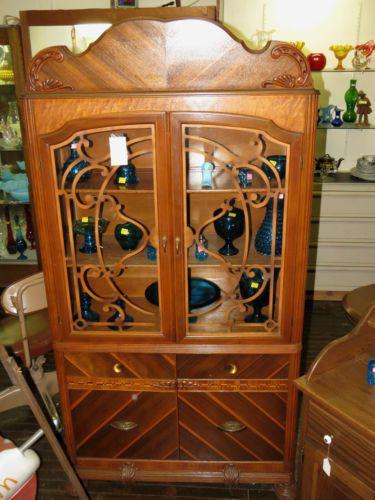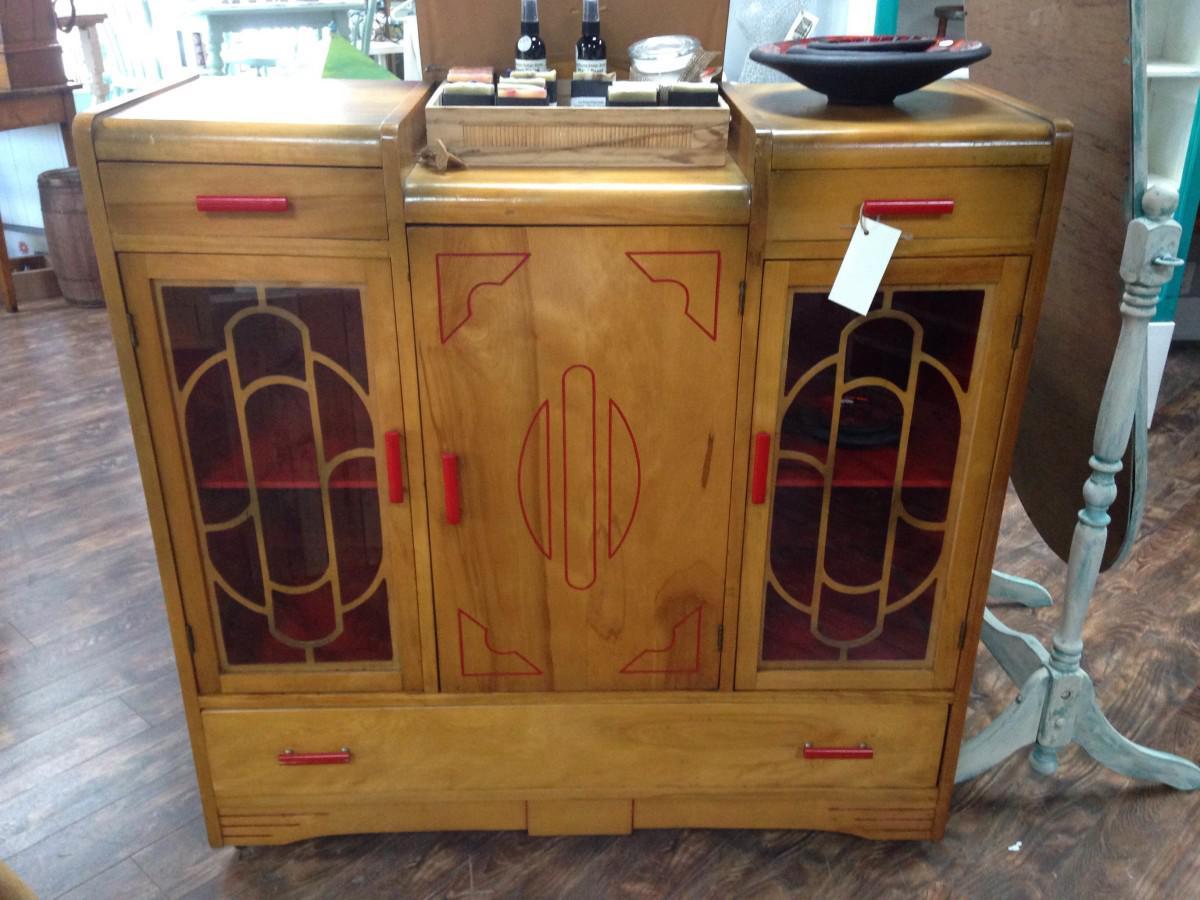The first image is the image on the left, the second image is the image on the right. Assess this claim about the two images: "Right image features a cabinet with slender feet instead of wedge feet.". Correct or not? Answer yes or no. No. The first image is the image on the left, the second image is the image on the right. Considering the images on both sides, is "One wooden cabinet on tall legs has a center rectangular glass panel on the front." valid? Answer yes or no. No. 